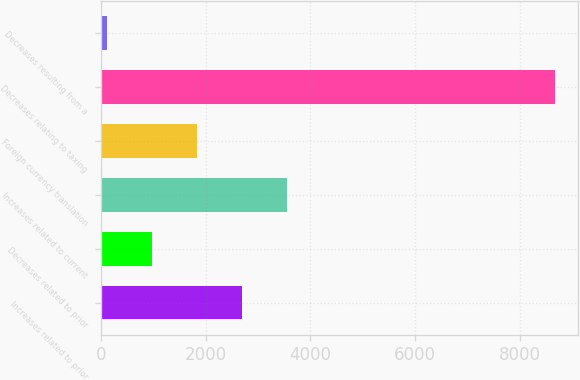Convert chart. <chart><loc_0><loc_0><loc_500><loc_500><bar_chart><fcel>Increases related to prior<fcel>Decreases related to prior<fcel>Increases related to current<fcel>Foreign currency translation<fcel>Decreases relating to taxing<fcel>Decreases resulting from a<nl><fcel>2691<fcel>981<fcel>3546<fcel>1836<fcel>8676<fcel>126<nl></chart> 